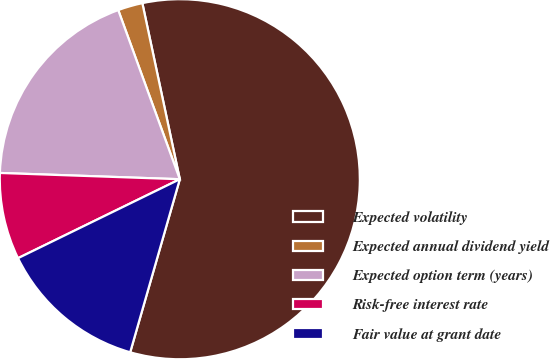Convert chart to OTSL. <chart><loc_0><loc_0><loc_500><loc_500><pie_chart><fcel>Expected volatility<fcel>Expected annual dividend yield<fcel>Expected option term (years)<fcel>Risk-free interest rate<fcel>Fair value at grant date<nl><fcel>57.78%<fcel>2.22%<fcel>18.89%<fcel>7.78%<fcel>13.33%<nl></chart> 